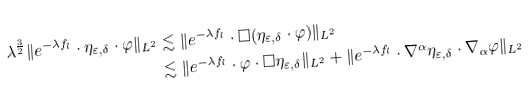<formula> <loc_0><loc_0><loc_500><loc_500>\lambda ^ { \frac { 3 } { 2 } } \| e ^ { - \lambda f _ { l } } \cdot \eta _ { \varepsilon , \delta } \cdot \varphi \| _ { L ^ { 2 } } & \lesssim \| e ^ { - \lambda f _ { l } } \cdot \Box ( \eta _ { \varepsilon , \delta } \cdot \varphi ) \| _ { L ^ { 2 } } \\ & \lesssim \| e ^ { - \lambda f _ { l } } \cdot \varphi \cdot \Box \eta _ { \varepsilon , \delta } \| _ { L ^ { 2 } } + \| e ^ { - \lambda f _ { l } } \cdot \nabla ^ { \alpha } \eta _ { \varepsilon , \delta } \cdot \nabla _ { \alpha } \varphi \| _ { L ^ { 2 } }</formula> 